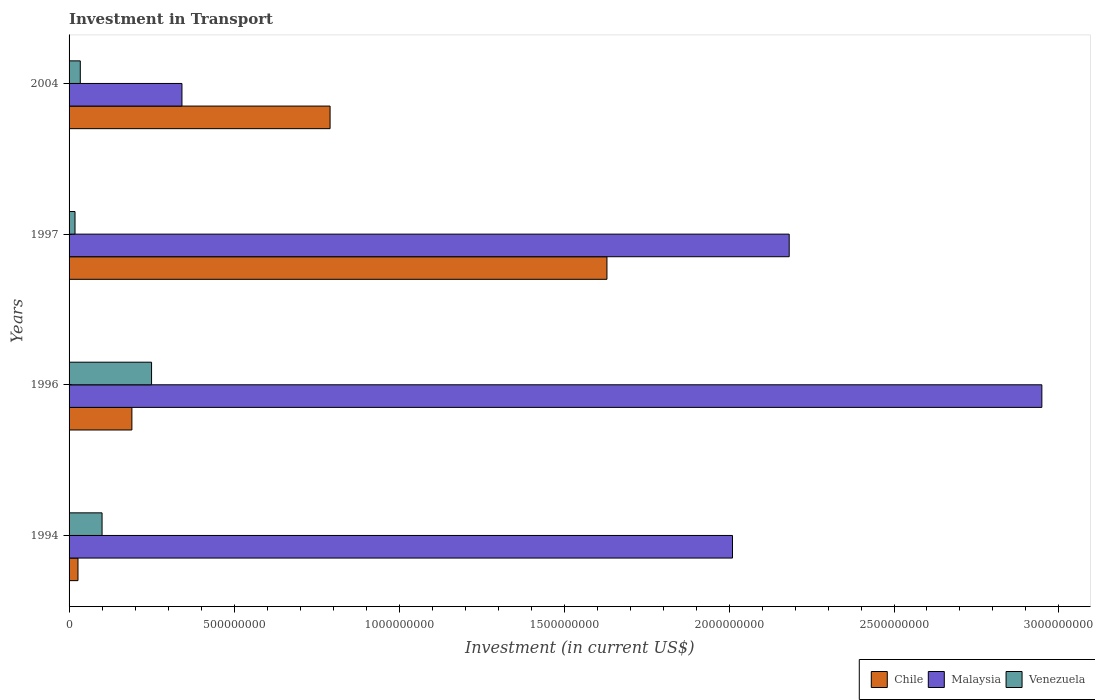Are the number of bars per tick equal to the number of legend labels?
Offer a very short reply. Yes. How many bars are there on the 2nd tick from the bottom?
Provide a succinct answer. 3. In how many cases, is the number of bars for a given year not equal to the number of legend labels?
Keep it short and to the point. 0. What is the amount invested in transport in Malaysia in 1994?
Keep it short and to the point. 2.01e+09. Across all years, what is the maximum amount invested in transport in Venezuela?
Make the answer very short. 2.50e+08. Across all years, what is the minimum amount invested in transport in Chile?
Make the answer very short. 2.70e+07. In which year was the amount invested in transport in Venezuela maximum?
Offer a very short reply. 1996. What is the total amount invested in transport in Venezuela in the graph?
Make the answer very short. 4.02e+08. What is the difference between the amount invested in transport in Venezuela in 1996 and that in 1997?
Provide a short and direct response. 2.32e+08. What is the difference between the amount invested in transport in Malaysia in 1994 and the amount invested in transport in Venezuela in 1996?
Make the answer very short. 1.76e+09. What is the average amount invested in transport in Venezuela per year?
Your response must be concise. 1.00e+08. In the year 1997, what is the difference between the amount invested in transport in Chile and amount invested in transport in Venezuela?
Your response must be concise. 1.61e+09. In how many years, is the amount invested in transport in Venezuela greater than 2100000000 US$?
Your response must be concise. 0. What is the ratio of the amount invested in transport in Venezuela in 1994 to that in 2004?
Ensure brevity in your answer.  2.94. Is the difference between the amount invested in transport in Chile in 1994 and 2004 greater than the difference between the amount invested in transport in Venezuela in 1994 and 2004?
Your answer should be compact. No. What is the difference between the highest and the second highest amount invested in transport in Venezuela?
Your response must be concise. 1.50e+08. What is the difference between the highest and the lowest amount invested in transport in Venezuela?
Make the answer very short. 2.32e+08. In how many years, is the amount invested in transport in Venezuela greater than the average amount invested in transport in Venezuela taken over all years?
Offer a very short reply. 1. What does the 1st bar from the top in 1997 represents?
Your answer should be very brief. Venezuela. What does the 3rd bar from the bottom in 1994 represents?
Make the answer very short. Venezuela. Is it the case that in every year, the sum of the amount invested in transport in Chile and amount invested in transport in Venezuela is greater than the amount invested in transport in Malaysia?
Your response must be concise. No. What is the difference between two consecutive major ticks on the X-axis?
Offer a terse response. 5.00e+08. Does the graph contain any zero values?
Give a very brief answer. No. Where does the legend appear in the graph?
Your answer should be compact. Bottom right. What is the title of the graph?
Provide a succinct answer. Investment in Transport. Does "Panama" appear as one of the legend labels in the graph?
Your response must be concise. No. What is the label or title of the X-axis?
Make the answer very short. Investment (in current US$). What is the Investment (in current US$) of Chile in 1994?
Provide a succinct answer. 2.70e+07. What is the Investment (in current US$) in Malaysia in 1994?
Make the answer very short. 2.01e+09. What is the Investment (in current US$) of Chile in 1996?
Your answer should be very brief. 1.90e+08. What is the Investment (in current US$) of Malaysia in 1996?
Give a very brief answer. 2.95e+09. What is the Investment (in current US$) in Venezuela in 1996?
Offer a terse response. 2.50e+08. What is the Investment (in current US$) in Chile in 1997?
Ensure brevity in your answer.  1.63e+09. What is the Investment (in current US$) in Malaysia in 1997?
Make the answer very short. 2.18e+09. What is the Investment (in current US$) in Venezuela in 1997?
Your answer should be very brief. 1.80e+07. What is the Investment (in current US$) in Chile in 2004?
Your response must be concise. 7.91e+08. What is the Investment (in current US$) in Malaysia in 2004?
Provide a short and direct response. 3.42e+08. What is the Investment (in current US$) in Venezuela in 2004?
Your answer should be very brief. 3.40e+07. Across all years, what is the maximum Investment (in current US$) in Chile?
Offer a very short reply. 1.63e+09. Across all years, what is the maximum Investment (in current US$) in Malaysia?
Your answer should be compact. 2.95e+09. Across all years, what is the maximum Investment (in current US$) in Venezuela?
Your answer should be compact. 2.50e+08. Across all years, what is the minimum Investment (in current US$) of Chile?
Keep it short and to the point. 2.70e+07. Across all years, what is the minimum Investment (in current US$) of Malaysia?
Your answer should be very brief. 3.42e+08. Across all years, what is the minimum Investment (in current US$) in Venezuela?
Your answer should be very brief. 1.80e+07. What is the total Investment (in current US$) of Chile in the graph?
Offer a very short reply. 2.64e+09. What is the total Investment (in current US$) of Malaysia in the graph?
Your response must be concise. 7.48e+09. What is the total Investment (in current US$) in Venezuela in the graph?
Your response must be concise. 4.02e+08. What is the difference between the Investment (in current US$) of Chile in 1994 and that in 1996?
Your answer should be compact. -1.63e+08. What is the difference between the Investment (in current US$) of Malaysia in 1994 and that in 1996?
Offer a very short reply. -9.38e+08. What is the difference between the Investment (in current US$) of Venezuela in 1994 and that in 1996?
Your answer should be very brief. -1.50e+08. What is the difference between the Investment (in current US$) of Chile in 1994 and that in 1997?
Offer a very short reply. -1.60e+09. What is the difference between the Investment (in current US$) in Malaysia in 1994 and that in 1997?
Ensure brevity in your answer.  -1.72e+08. What is the difference between the Investment (in current US$) of Venezuela in 1994 and that in 1997?
Give a very brief answer. 8.20e+07. What is the difference between the Investment (in current US$) of Chile in 1994 and that in 2004?
Provide a short and direct response. -7.64e+08. What is the difference between the Investment (in current US$) of Malaysia in 1994 and that in 2004?
Make the answer very short. 1.67e+09. What is the difference between the Investment (in current US$) in Venezuela in 1994 and that in 2004?
Provide a short and direct response. 6.60e+07. What is the difference between the Investment (in current US$) of Chile in 1996 and that in 1997?
Your answer should be very brief. -1.44e+09. What is the difference between the Investment (in current US$) in Malaysia in 1996 and that in 1997?
Your answer should be very brief. 7.66e+08. What is the difference between the Investment (in current US$) of Venezuela in 1996 and that in 1997?
Keep it short and to the point. 2.32e+08. What is the difference between the Investment (in current US$) in Chile in 1996 and that in 2004?
Your response must be concise. -6.01e+08. What is the difference between the Investment (in current US$) of Malaysia in 1996 and that in 2004?
Provide a short and direct response. 2.61e+09. What is the difference between the Investment (in current US$) of Venezuela in 1996 and that in 2004?
Your answer should be very brief. 2.16e+08. What is the difference between the Investment (in current US$) of Chile in 1997 and that in 2004?
Your response must be concise. 8.39e+08. What is the difference between the Investment (in current US$) of Malaysia in 1997 and that in 2004?
Keep it short and to the point. 1.84e+09. What is the difference between the Investment (in current US$) of Venezuela in 1997 and that in 2004?
Offer a very short reply. -1.60e+07. What is the difference between the Investment (in current US$) of Chile in 1994 and the Investment (in current US$) of Malaysia in 1996?
Give a very brief answer. -2.92e+09. What is the difference between the Investment (in current US$) of Chile in 1994 and the Investment (in current US$) of Venezuela in 1996?
Offer a very short reply. -2.23e+08. What is the difference between the Investment (in current US$) of Malaysia in 1994 and the Investment (in current US$) of Venezuela in 1996?
Keep it short and to the point. 1.76e+09. What is the difference between the Investment (in current US$) in Chile in 1994 and the Investment (in current US$) in Malaysia in 1997?
Offer a terse response. -2.16e+09. What is the difference between the Investment (in current US$) in Chile in 1994 and the Investment (in current US$) in Venezuela in 1997?
Your answer should be compact. 9.00e+06. What is the difference between the Investment (in current US$) in Malaysia in 1994 and the Investment (in current US$) in Venezuela in 1997?
Ensure brevity in your answer.  1.99e+09. What is the difference between the Investment (in current US$) of Chile in 1994 and the Investment (in current US$) of Malaysia in 2004?
Your answer should be very brief. -3.15e+08. What is the difference between the Investment (in current US$) of Chile in 1994 and the Investment (in current US$) of Venezuela in 2004?
Offer a terse response. -7.00e+06. What is the difference between the Investment (in current US$) in Malaysia in 1994 and the Investment (in current US$) in Venezuela in 2004?
Offer a very short reply. 1.98e+09. What is the difference between the Investment (in current US$) of Chile in 1996 and the Investment (in current US$) of Malaysia in 1997?
Give a very brief answer. -1.99e+09. What is the difference between the Investment (in current US$) in Chile in 1996 and the Investment (in current US$) in Venezuela in 1997?
Your answer should be compact. 1.72e+08. What is the difference between the Investment (in current US$) in Malaysia in 1996 and the Investment (in current US$) in Venezuela in 1997?
Give a very brief answer. 2.93e+09. What is the difference between the Investment (in current US$) of Chile in 1996 and the Investment (in current US$) of Malaysia in 2004?
Provide a succinct answer. -1.52e+08. What is the difference between the Investment (in current US$) in Chile in 1996 and the Investment (in current US$) in Venezuela in 2004?
Your answer should be very brief. 1.56e+08. What is the difference between the Investment (in current US$) of Malaysia in 1996 and the Investment (in current US$) of Venezuela in 2004?
Your response must be concise. 2.91e+09. What is the difference between the Investment (in current US$) in Chile in 1997 and the Investment (in current US$) in Malaysia in 2004?
Your answer should be very brief. 1.29e+09. What is the difference between the Investment (in current US$) of Chile in 1997 and the Investment (in current US$) of Venezuela in 2004?
Keep it short and to the point. 1.60e+09. What is the difference between the Investment (in current US$) of Malaysia in 1997 and the Investment (in current US$) of Venezuela in 2004?
Make the answer very short. 2.15e+09. What is the average Investment (in current US$) in Chile per year?
Your answer should be compact. 6.60e+08. What is the average Investment (in current US$) of Malaysia per year?
Provide a short and direct response. 1.87e+09. What is the average Investment (in current US$) of Venezuela per year?
Offer a terse response. 1.00e+08. In the year 1994, what is the difference between the Investment (in current US$) of Chile and Investment (in current US$) of Malaysia?
Ensure brevity in your answer.  -1.98e+09. In the year 1994, what is the difference between the Investment (in current US$) in Chile and Investment (in current US$) in Venezuela?
Keep it short and to the point. -7.30e+07. In the year 1994, what is the difference between the Investment (in current US$) in Malaysia and Investment (in current US$) in Venezuela?
Offer a very short reply. 1.91e+09. In the year 1996, what is the difference between the Investment (in current US$) of Chile and Investment (in current US$) of Malaysia?
Your answer should be very brief. -2.76e+09. In the year 1996, what is the difference between the Investment (in current US$) in Chile and Investment (in current US$) in Venezuela?
Offer a very short reply. -5.96e+07. In the year 1996, what is the difference between the Investment (in current US$) in Malaysia and Investment (in current US$) in Venezuela?
Your answer should be compact. 2.70e+09. In the year 1997, what is the difference between the Investment (in current US$) in Chile and Investment (in current US$) in Malaysia?
Your response must be concise. -5.52e+08. In the year 1997, what is the difference between the Investment (in current US$) in Chile and Investment (in current US$) in Venezuela?
Ensure brevity in your answer.  1.61e+09. In the year 1997, what is the difference between the Investment (in current US$) in Malaysia and Investment (in current US$) in Venezuela?
Offer a very short reply. 2.16e+09. In the year 2004, what is the difference between the Investment (in current US$) in Chile and Investment (in current US$) in Malaysia?
Your answer should be very brief. 4.49e+08. In the year 2004, what is the difference between the Investment (in current US$) of Chile and Investment (in current US$) of Venezuela?
Offer a very short reply. 7.57e+08. In the year 2004, what is the difference between the Investment (in current US$) in Malaysia and Investment (in current US$) in Venezuela?
Give a very brief answer. 3.08e+08. What is the ratio of the Investment (in current US$) of Chile in 1994 to that in 1996?
Keep it short and to the point. 0.14. What is the ratio of the Investment (in current US$) of Malaysia in 1994 to that in 1996?
Ensure brevity in your answer.  0.68. What is the ratio of the Investment (in current US$) in Venezuela in 1994 to that in 1996?
Provide a short and direct response. 0.4. What is the ratio of the Investment (in current US$) of Chile in 1994 to that in 1997?
Provide a short and direct response. 0.02. What is the ratio of the Investment (in current US$) of Malaysia in 1994 to that in 1997?
Keep it short and to the point. 0.92. What is the ratio of the Investment (in current US$) in Venezuela in 1994 to that in 1997?
Your answer should be very brief. 5.56. What is the ratio of the Investment (in current US$) in Chile in 1994 to that in 2004?
Your response must be concise. 0.03. What is the ratio of the Investment (in current US$) of Malaysia in 1994 to that in 2004?
Make the answer very short. 5.88. What is the ratio of the Investment (in current US$) of Venezuela in 1994 to that in 2004?
Provide a succinct answer. 2.94. What is the ratio of the Investment (in current US$) of Chile in 1996 to that in 1997?
Your answer should be very brief. 0.12. What is the ratio of the Investment (in current US$) in Malaysia in 1996 to that in 1997?
Your response must be concise. 1.35. What is the ratio of the Investment (in current US$) of Venezuela in 1996 to that in 1997?
Your answer should be very brief. 13.89. What is the ratio of the Investment (in current US$) in Chile in 1996 to that in 2004?
Make the answer very short. 0.24. What is the ratio of the Investment (in current US$) of Malaysia in 1996 to that in 2004?
Keep it short and to the point. 8.62. What is the ratio of the Investment (in current US$) in Venezuela in 1996 to that in 2004?
Your response must be concise. 7.35. What is the ratio of the Investment (in current US$) of Chile in 1997 to that in 2004?
Your response must be concise. 2.06. What is the ratio of the Investment (in current US$) in Malaysia in 1997 to that in 2004?
Ensure brevity in your answer.  6.38. What is the ratio of the Investment (in current US$) in Venezuela in 1997 to that in 2004?
Provide a succinct answer. 0.53. What is the difference between the highest and the second highest Investment (in current US$) in Chile?
Offer a terse response. 8.39e+08. What is the difference between the highest and the second highest Investment (in current US$) of Malaysia?
Your response must be concise. 7.66e+08. What is the difference between the highest and the second highest Investment (in current US$) of Venezuela?
Offer a very short reply. 1.50e+08. What is the difference between the highest and the lowest Investment (in current US$) of Chile?
Your answer should be compact. 1.60e+09. What is the difference between the highest and the lowest Investment (in current US$) of Malaysia?
Make the answer very short. 2.61e+09. What is the difference between the highest and the lowest Investment (in current US$) of Venezuela?
Your response must be concise. 2.32e+08. 